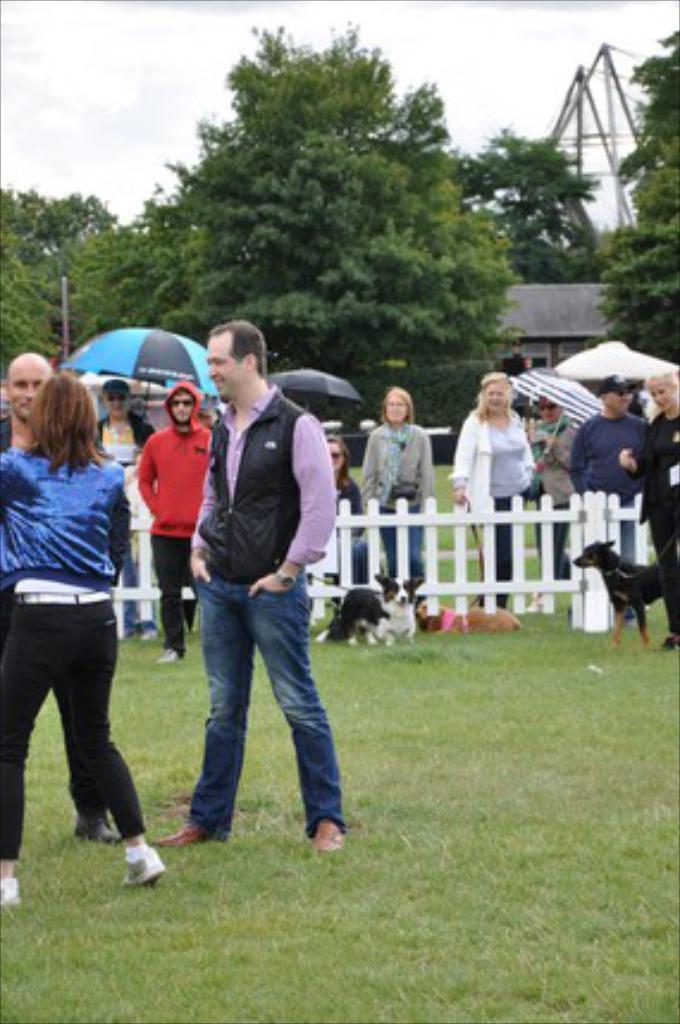Please provide a concise description of this image. This is an outside view. Here I can see few people are standing. It is looking like a playing ground. Along with the people there are three dogs. In the background I can see the trees in green color in the sky. Here I can see two people are holding umbrellas in their hands. 